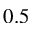Convert formula to latex. <formula><loc_0><loc_0><loc_500><loc_500>0 . 5</formula> 